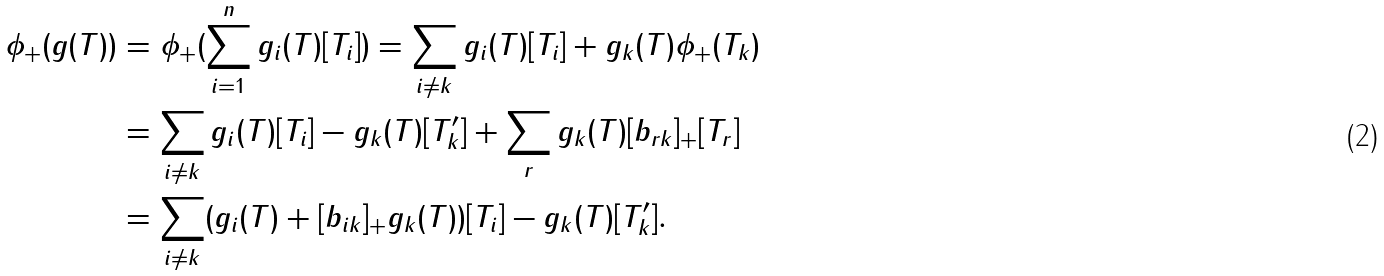Convert formula to latex. <formula><loc_0><loc_0><loc_500><loc_500>\phi _ { + } ( g ( T ) ) & = \phi _ { + } ( \sum ^ { n } _ { i = 1 } g _ { i } ( T ) [ T _ { i } ] ) = \sum _ { i \neq k } g _ { i } ( T ) [ T _ { i } ] + g _ { k } ( T ) \phi _ { + } ( T _ { k } ) \\ & = \sum _ { i \neq k } g _ { i } ( T ) [ T _ { i } ] - g _ { k } ( T ) [ T ^ { \prime } _ { k } ] + \sum _ { r } g _ { k } ( T ) [ b _ { r k } ] _ { + } [ T _ { r } ] \\ & = \sum _ { i \neq k } ( g _ { i } ( T ) + [ b _ { i k } ] _ { + } g _ { k } ( T ) ) [ T _ { i } ] - g _ { k } ( T ) [ T ^ { \prime } _ { k } ] .</formula> 